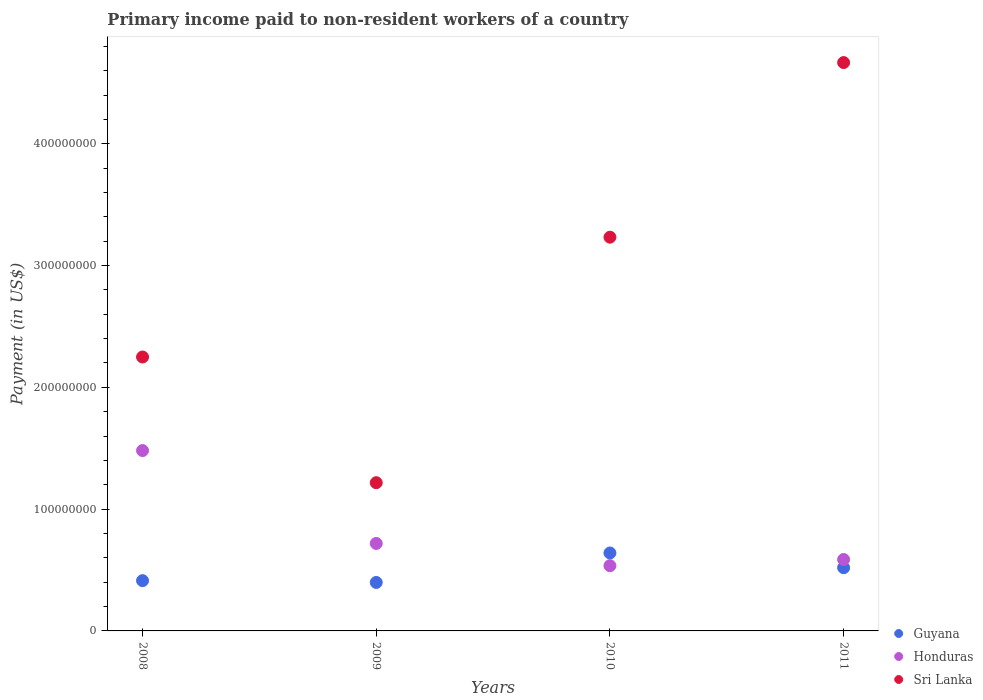How many different coloured dotlines are there?
Provide a succinct answer. 3. Is the number of dotlines equal to the number of legend labels?
Offer a terse response. Yes. What is the amount paid to workers in Guyana in 2008?
Provide a short and direct response. 4.13e+07. Across all years, what is the maximum amount paid to workers in Guyana?
Provide a succinct answer. 6.40e+07. Across all years, what is the minimum amount paid to workers in Sri Lanka?
Your answer should be very brief. 1.22e+08. What is the total amount paid to workers in Guyana in the graph?
Keep it short and to the point. 1.97e+08. What is the difference between the amount paid to workers in Honduras in 2008 and that in 2009?
Offer a very short reply. 7.63e+07. What is the difference between the amount paid to workers in Sri Lanka in 2010 and the amount paid to workers in Guyana in 2008?
Your answer should be compact. 2.82e+08. What is the average amount paid to workers in Guyana per year?
Your response must be concise. 4.92e+07. In the year 2011, what is the difference between the amount paid to workers in Guyana and amount paid to workers in Sri Lanka?
Give a very brief answer. -4.15e+08. What is the ratio of the amount paid to workers in Sri Lanka in 2009 to that in 2010?
Make the answer very short. 0.38. What is the difference between the highest and the second highest amount paid to workers in Sri Lanka?
Provide a succinct answer. 1.43e+08. What is the difference between the highest and the lowest amount paid to workers in Honduras?
Provide a short and direct response. 9.45e+07. In how many years, is the amount paid to workers in Sri Lanka greater than the average amount paid to workers in Sri Lanka taken over all years?
Offer a terse response. 2. Is the sum of the amount paid to workers in Honduras in 2008 and 2009 greater than the maximum amount paid to workers in Guyana across all years?
Ensure brevity in your answer.  Yes. Does the amount paid to workers in Sri Lanka monotonically increase over the years?
Make the answer very short. No. Is the amount paid to workers in Honduras strictly greater than the amount paid to workers in Guyana over the years?
Keep it short and to the point. No. Does the graph contain any zero values?
Provide a succinct answer. No. Where does the legend appear in the graph?
Offer a terse response. Bottom right. How many legend labels are there?
Provide a succinct answer. 3. What is the title of the graph?
Provide a short and direct response. Primary income paid to non-resident workers of a country. What is the label or title of the X-axis?
Your response must be concise. Years. What is the label or title of the Y-axis?
Give a very brief answer. Payment (in US$). What is the Payment (in US$) of Guyana in 2008?
Your answer should be compact. 4.13e+07. What is the Payment (in US$) of Honduras in 2008?
Keep it short and to the point. 1.48e+08. What is the Payment (in US$) in Sri Lanka in 2008?
Provide a short and direct response. 2.25e+08. What is the Payment (in US$) of Guyana in 2009?
Keep it short and to the point. 3.98e+07. What is the Payment (in US$) of Honduras in 2009?
Provide a short and direct response. 7.18e+07. What is the Payment (in US$) of Sri Lanka in 2009?
Your response must be concise. 1.22e+08. What is the Payment (in US$) of Guyana in 2010?
Your answer should be compact. 6.40e+07. What is the Payment (in US$) in Honduras in 2010?
Provide a succinct answer. 5.36e+07. What is the Payment (in US$) of Sri Lanka in 2010?
Keep it short and to the point. 3.23e+08. What is the Payment (in US$) in Guyana in 2011?
Your answer should be compact. 5.19e+07. What is the Payment (in US$) of Honduras in 2011?
Make the answer very short. 5.86e+07. What is the Payment (in US$) of Sri Lanka in 2011?
Give a very brief answer. 4.67e+08. Across all years, what is the maximum Payment (in US$) in Guyana?
Keep it short and to the point. 6.40e+07. Across all years, what is the maximum Payment (in US$) in Honduras?
Make the answer very short. 1.48e+08. Across all years, what is the maximum Payment (in US$) in Sri Lanka?
Ensure brevity in your answer.  4.67e+08. Across all years, what is the minimum Payment (in US$) in Guyana?
Ensure brevity in your answer.  3.98e+07. Across all years, what is the minimum Payment (in US$) in Honduras?
Give a very brief answer. 5.36e+07. Across all years, what is the minimum Payment (in US$) in Sri Lanka?
Ensure brevity in your answer.  1.22e+08. What is the total Payment (in US$) in Guyana in the graph?
Offer a terse response. 1.97e+08. What is the total Payment (in US$) in Honduras in the graph?
Make the answer very short. 3.32e+08. What is the total Payment (in US$) of Sri Lanka in the graph?
Your answer should be compact. 1.14e+09. What is the difference between the Payment (in US$) of Guyana in 2008 and that in 2009?
Offer a very short reply. 1.47e+06. What is the difference between the Payment (in US$) of Honduras in 2008 and that in 2009?
Make the answer very short. 7.63e+07. What is the difference between the Payment (in US$) in Sri Lanka in 2008 and that in 2009?
Provide a succinct answer. 1.03e+08. What is the difference between the Payment (in US$) in Guyana in 2008 and that in 2010?
Provide a succinct answer. -2.27e+07. What is the difference between the Payment (in US$) in Honduras in 2008 and that in 2010?
Ensure brevity in your answer.  9.45e+07. What is the difference between the Payment (in US$) in Sri Lanka in 2008 and that in 2010?
Your answer should be compact. -9.84e+07. What is the difference between the Payment (in US$) of Guyana in 2008 and that in 2011?
Your response must be concise. -1.06e+07. What is the difference between the Payment (in US$) in Honduras in 2008 and that in 2011?
Ensure brevity in your answer.  8.94e+07. What is the difference between the Payment (in US$) in Sri Lanka in 2008 and that in 2011?
Provide a succinct answer. -2.42e+08. What is the difference between the Payment (in US$) in Guyana in 2009 and that in 2010?
Keep it short and to the point. -2.42e+07. What is the difference between the Payment (in US$) of Honduras in 2009 and that in 2010?
Your response must be concise. 1.83e+07. What is the difference between the Payment (in US$) in Sri Lanka in 2009 and that in 2010?
Your answer should be compact. -2.02e+08. What is the difference between the Payment (in US$) of Guyana in 2009 and that in 2011?
Your answer should be very brief. -1.21e+07. What is the difference between the Payment (in US$) in Honduras in 2009 and that in 2011?
Give a very brief answer. 1.32e+07. What is the difference between the Payment (in US$) in Sri Lanka in 2009 and that in 2011?
Your response must be concise. -3.45e+08. What is the difference between the Payment (in US$) in Guyana in 2010 and that in 2011?
Offer a terse response. 1.21e+07. What is the difference between the Payment (in US$) in Honduras in 2010 and that in 2011?
Your response must be concise. -5.07e+06. What is the difference between the Payment (in US$) of Sri Lanka in 2010 and that in 2011?
Make the answer very short. -1.43e+08. What is the difference between the Payment (in US$) of Guyana in 2008 and the Payment (in US$) of Honduras in 2009?
Ensure brevity in your answer.  -3.06e+07. What is the difference between the Payment (in US$) of Guyana in 2008 and the Payment (in US$) of Sri Lanka in 2009?
Make the answer very short. -8.04e+07. What is the difference between the Payment (in US$) of Honduras in 2008 and the Payment (in US$) of Sri Lanka in 2009?
Your answer should be compact. 2.64e+07. What is the difference between the Payment (in US$) of Guyana in 2008 and the Payment (in US$) of Honduras in 2010?
Your answer should be very brief. -1.23e+07. What is the difference between the Payment (in US$) in Guyana in 2008 and the Payment (in US$) in Sri Lanka in 2010?
Provide a short and direct response. -2.82e+08. What is the difference between the Payment (in US$) in Honduras in 2008 and the Payment (in US$) in Sri Lanka in 2010?
Offer a very short reply. -1.75e+08. What is the difference between the Payment (in US$) of Guyana in 2008 and the Payment (in US$) of Honduras in 2011?
Your response must be concise. -1.74e+07. What is the difference between the Payment (in US$) of Guyana in 2008 and the Payment (in US$) of Sri Lanka in 2011?
Make the answer very short. -4.25e+08. What is the difference between the Payment (in US$) of Honduras in 2008 and the Payment (in US$) of Sri Lanka in 2011?
Your answer should be compact. -3.19e+08. What is the difference between the Payment (in US$) of Guyana in 2009 and the Payment (in US$) of Honduras in 2010?
Keep it short and to the point. -1.38e+07. What is the difference between the Payment (in US$) of Guyana in 2009 and the Payment (in US$) of Sri Lanka in 2010?
Your answer should be compact. -2.83e+08. What is the difference between the Payment (in US$) of Honduras in 2009 and the Payment (in US$) of Sri Lanka in 2010?
Your answer should be very brief. -2.51e+08. What is the difference between the Payment (in US$) in Guyana in 2009 and the Payment (in US$) in Honduras in 2011?
Offer a terse response. -1.88e+07. What is the difference between the Payment (in US$) of Guyana in 2009 and the Payment (in US$) of Sri Lanka in 2011?
Provide a short and direct response. -4.27e+08. What is the difference between the Payment (in US$) of Honduras in 2009 and the Payment (in US$) of Sri Lanka in 2011?
Offer a very short reply. -3.95e+08. What is the difference between the Payment (in US$) of Guyana in 2010 and the Payment (in US$) of Honduras in 2011?
Ensure brevity in your answer.  5.36e+06. What is the difference between the Payment (in US$) in Guyana in 2010 and the Payment (in US$) in Sri Lanka in 2011?
Ensure brevity in your answer.  -4.03e+08. What is the difference between the Payment (in US$) of Honduras in 2010 and the Payment (in US$) of Sri Lanka in 2011?
Your response must be concise. -4.13e+08. What is the average Payment (in US$) in Guyana per year?
Offer a very short reply. 4.92e+07. What is the average Payment (in US$) of Honduras per year?
Offer a terse response. 8.30e+07. What is the average Payment (in US$) in Sri Lanka per year?
Your answer should be very brief. 2.84e+08. In the year 2008, what is the difference between the Payment (in US$) in Guyana and Payment (in US$) in Honduras?
Ensure brevity in your answer.  -1.07e+08. In the year 2008, what is the difference between the Payment (in US$) of Guyana and Payment (in US$) of Sri Lanka?
Offer a very short reply. -1.84e+08. In the year 2008, what is the difference between the Payment (in US$) in Honduras and Payment (in US$) in Sri Lanka?
Ensure brevity in your answer.  -7.68e+07. In the year 2009, what is the difference between the Payment (in US$) in Guyana and Payment (in US$) in Honduras?
Your answer should be very brief. -3.20e+07. In the year 2009, what is the difference between the Payment (in US$) in Guyana and Payment (in US$) in Sri Lanka?
Provide a short and direct response. -8.19e+07. In the year 2009, what is the difference between the Payment (in US$) of Honduras and Payment (in US$) of Sri Lanka?
Your answer should be very brief. -4.99e+07. In the year 2010, what is the difference between the Payment (in US$) in Guyana and Payment (in US$) in Honduras?
Your answer should be very brief. 1.04e+07. In the year 2010, what is the difference between the Payment (in US$) in Guyana and Payment (in US$) in Sri Lanka?
Offer a terse response. -2.59e+08. In the year 2010, what is the difference between the Payment (in US$) in Honduras and Payment (in US$) in Sri Lanka?
Give a very brief answer. -2.70e+08. In the year 2011, what is the difference between the Payment (in US$) of Guyana and Payment (in US$) of Honduras?
Your answer should be compact. -6.74e+06. In the year 2011, what is the difference between the Payment (in US$) of Guyana and Payment (in US$) of Sri Lanka?
Keep it short and to the point. -4.15e+08. In the year 2011, what is the difference between the Payment (in US$) in Honduras and Payment (in US$) in Sri Lanka?
Your response must be concise. -4.08e+08. What is the ratio of the Payment (in US$) in Guyana in 2008 to that in 2009?
Make the answer very short. 1.04. What is the ratio of the Payment (in US$) in Honduras in 2008 to that in 2009?
Keep it short and to the point. 2.06. What is the ratio of the Payment (in US$) of Sri Lanka in 2008 to that in 2009?
Offer a very short reply. 1.85. What is the ratio of the Payment (in US$) in Guyana in 2008 to that in 2010?
Your answer should be very brief. 0.64. What is the ratio of the Payment (in US$) of Honduras in 2008 to that in 2010?
Make the answer very short. 2.76. What is the ratio of the Payment (in US$) of Sri Lanka in 2008 to that in 2010?
Ensure brevity in your answer.  0.7. What is the ratio of the Payment (in US$) of Guyana in 2008 to that in 2011?
Offer a terse response. 0.8. What is the ratio of the Payment (in US$) of Honduras in 2008 to that in 2011?
Make the answer very short. 2.53. What is the ratio of the Payment (in US$) in Sri Lanka in 2008 to that in 2011?
Your response must be concise. 0.48. What is the ratio of the Payment (in US$) of Guyana in 2009 to that in 2010?
Provide a short and direct response. 0.62. What is the ratio of the Payment (in US$) in Honduras in 2009 to that in 2010?
Ensure brevity in your answer.  1.34. What is the ratio of the Payment (in US$) of Sri Lanka in 2009 to that in 2010?
Keep it short and to the point. 0.38. What is the ratio of the Payment (in US$) of Guyana in 2009 to that in 2011?
Provide a succinct answer. 0.77. What is the ratio of the Payment (in US$) of Honduras in 2009 to that in 2011?
Offer a terse response. 1.22. What is the ratio of the Payment (in US$) in Sri Lanka in 2009 to that in 2011?
Keep it short and to the point. 0.26. What is the ratio of the Payment (in US$) in Guyana in 2010 to that in 2011?
Make the answer very short. 1.23. What is the ratio of the Payment (in US$) in Honduras in 2010 to that in 2011?
Give a very brief answer. 0.91. What is the ratio of the Payment (in US$) in Sri Lanka in 2010 to that in 2011?
Provide a short and direct response. 0.69. What is the difference between the highest and the second highest Payment (in US$) of Guyana?
Give a very brief answer. 1.21e+07. What is the difference between the highest and the second highest Payment (in US$) in Honduras?
Your answer should be compact. 7.63e+07. What is the difference between the highest and the second highest Payment (in US$) in Sri Lanka?
Your response must be concise. 1.43e+08. What is the difference between the highest and the lowest Payment (in US$) in Guyana?
Offer a very short reply. 2.42e+07. What is the difference between the highest and the lowest Payment (in US$) of Honduras?
Provide a short and direct response. 9.45e+07. What is the difference between the highest and the lowest Payment (in US$) in Sri Lanka?
Provide a short and direct response. 3.45e+08. 